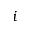Convert formula to latex. <formula><loc_0><loc_0><loc_500><loc_500>i</formula> 